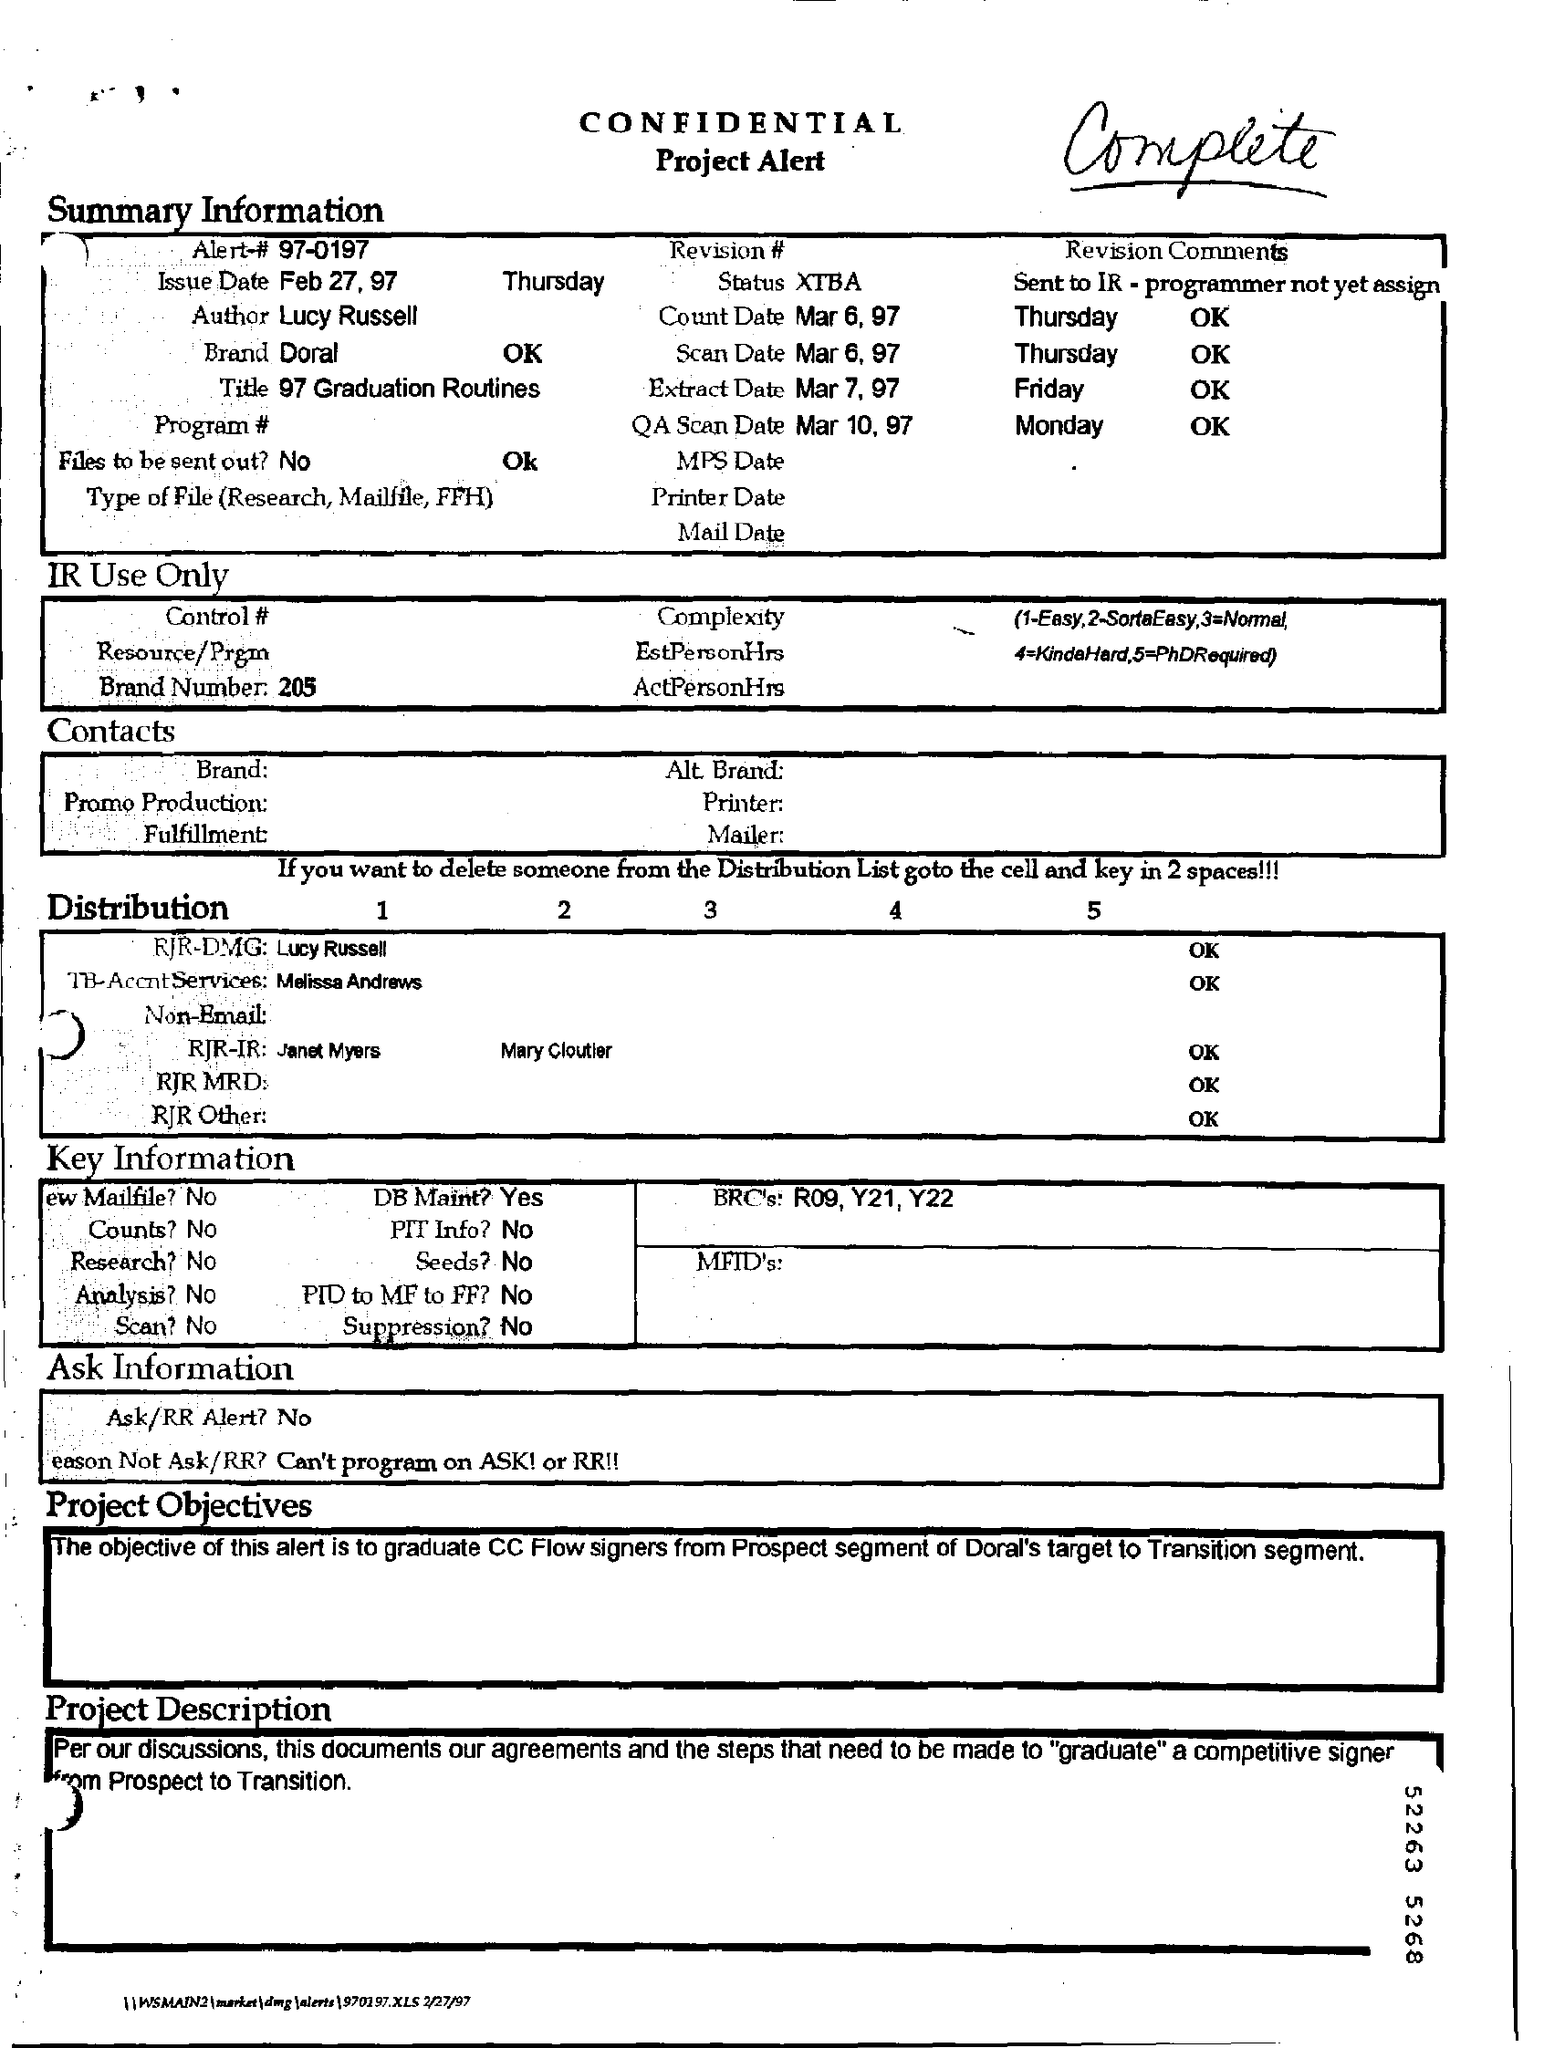Draw attention to some important aspects in this diagram. The status is XTBA... Doral is the brand that seeks to answer the question, 'What is the brand?' What is referred to as Alert #97-0197? The QA Scan Date is March 10, 1997. The scan date is March 6, 1997. 